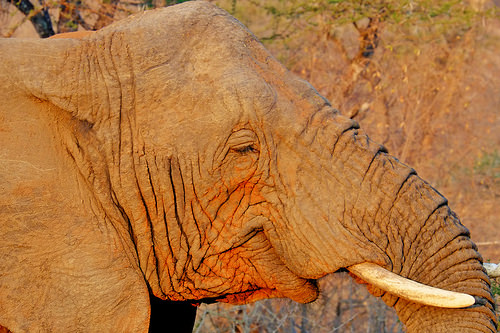<image>
Is there a tree to the right of the elephant? No. The tree is not to the right of the elephant. The horizontal positioning shows a different relationship. 